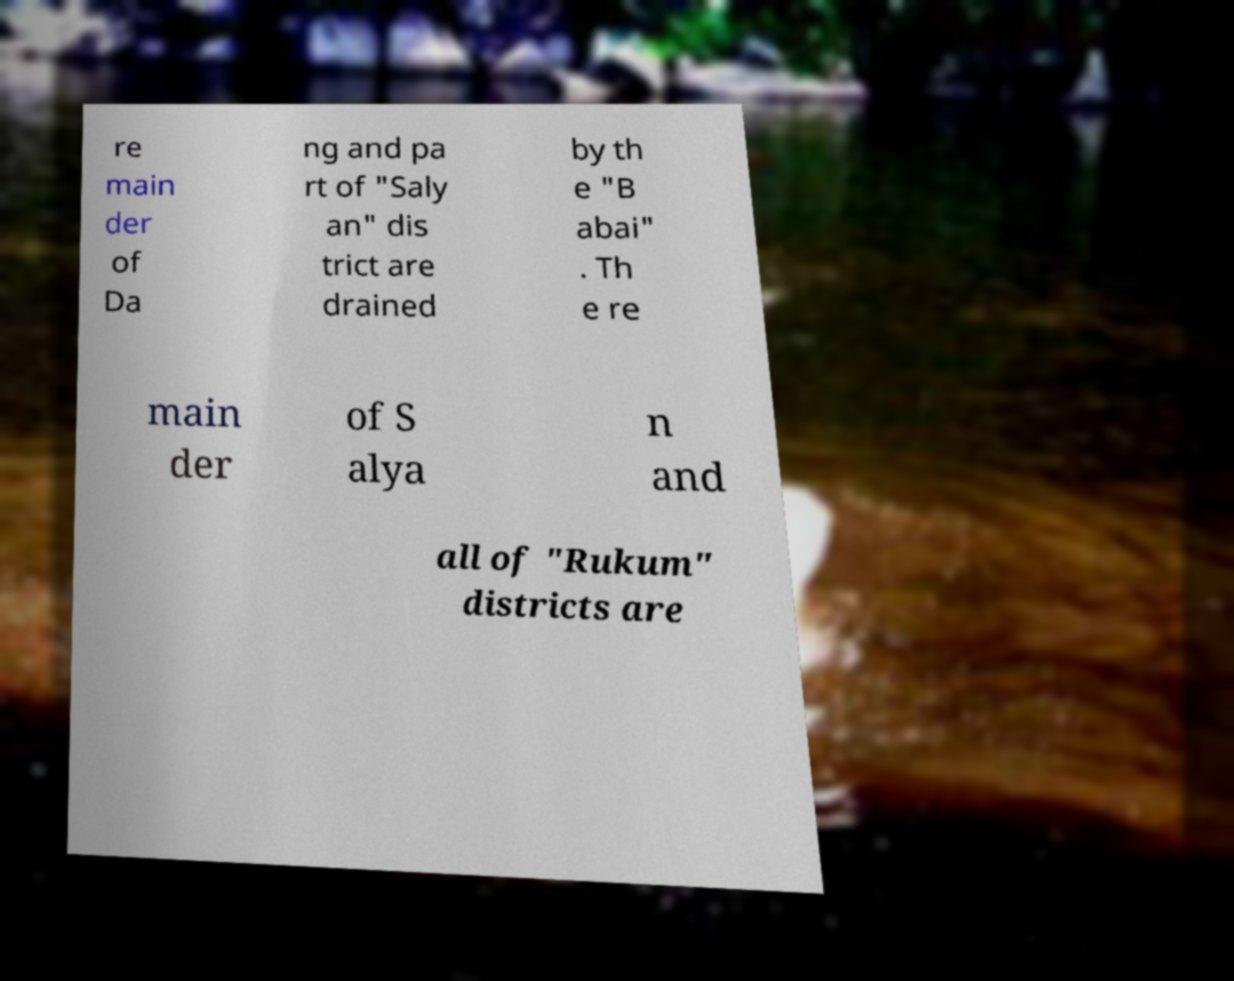There's text embedded in this image that I need extracted. Can you transcribe it verbatim? re main der of Da ng and pa rt of "Saly an" dis trict are drained by th e "B abai" . Th e re main der of S alya n and all of "Rukum" districts are 